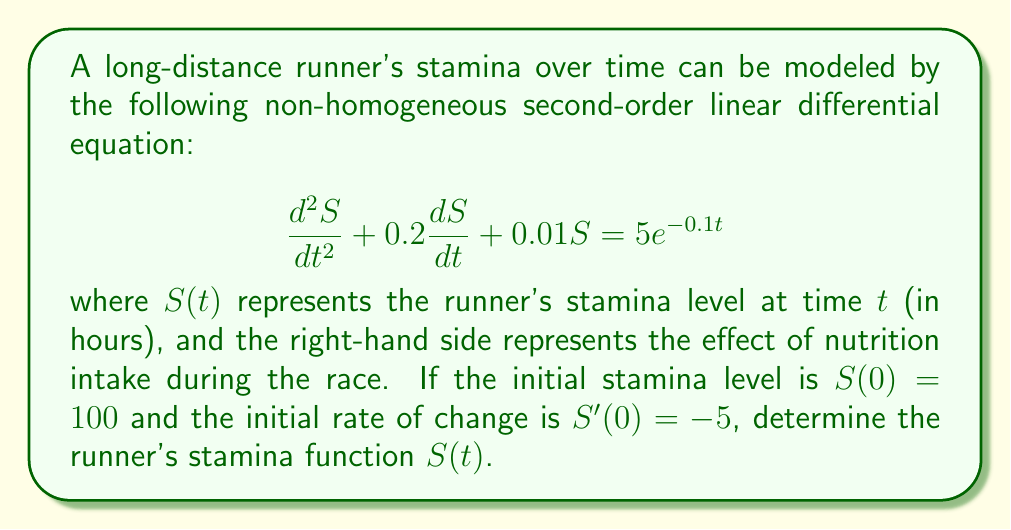Give your solution to this math problem. To solve this non-homogeneous second-order linear differential equation, we'll follow these steps:

1) First, we need to find the general solution to the homogeneous equation:
   $$\frac{d^2S}{dt^2} + 0.2\frac{dS}{dt} + 0.01S = 0$$

   The characteristic equation is:
   $$r^2 + 0.2r + 0.01 = 0$$

   Solving this quadratic equation:
   $$r = \frac{-0.2 \pm \sqrt{0.2^2 - 4(1)(0.01)}}{2(1)} = -0.1 \pm 0.1i$$

   Therefore, the general solution to the homogeneous equation is:
   $$S_h(t) = e^{-0.1t}(C_1\cos(0.1t) + C_2\sin(0.1t))$$

2) Next, we need to find a particular solution to the non-homogeneous equation. We can use the method of undetermined coefficients. Let's try:
   $$S_p(t) = Ae^{-0.1t}$$

   Substituting this into the original equation:
   $$0.01Ae^{-0.1t} - 0.02Ae^{-0.1t} + 0.01Ae^{-0.1t} = 5e^{-0.1t}$$
   $$0 = 5e^{-0.1t}$$
   $$A = 500$$

   So, the particular solution is:
   $$S_p(t) = 500e^{-0.1t}$$

3) The general solution is the sum of the homogeneous and particular solutions:
   $$S(t) = e^{-0.1t}(C_1\cos(0.1t) + C_2\sin(0.1t)) + 500e^{-0.1t}$$

4) Now we use the initial conditions to find $C_1$ and $C_2$:
   
   For $S(0) = 100$:
   $$100 = C_1 + 500$$
   $$C_1 = -400$$

   For $S'(0) = -5$:
   $$-5 = -0.1(-400) + 0.1C_2 - 50$$
   $$C_2 = 450$$

5) Therefore, the final solution is:
   $$S(t) = e^{-0.1t}(-400\cos(0.1t) + 450\sin(0.1t)) + 500e^{-0.1t}$$
Answer: $S(t) = e^{-0.1t}(-400\cos(0.1t) + 450\sin(0.1t)) + 500e^{-0.1t}$ 